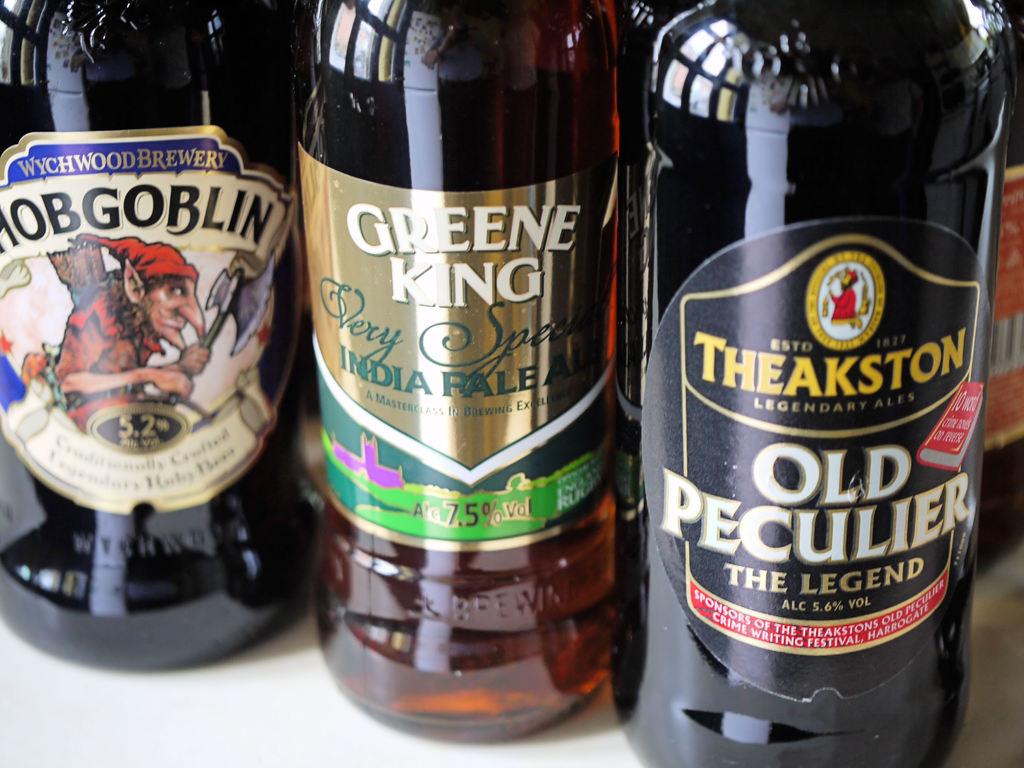What is the name of the right beer?
Provide a short and direct response. Old peculier. 